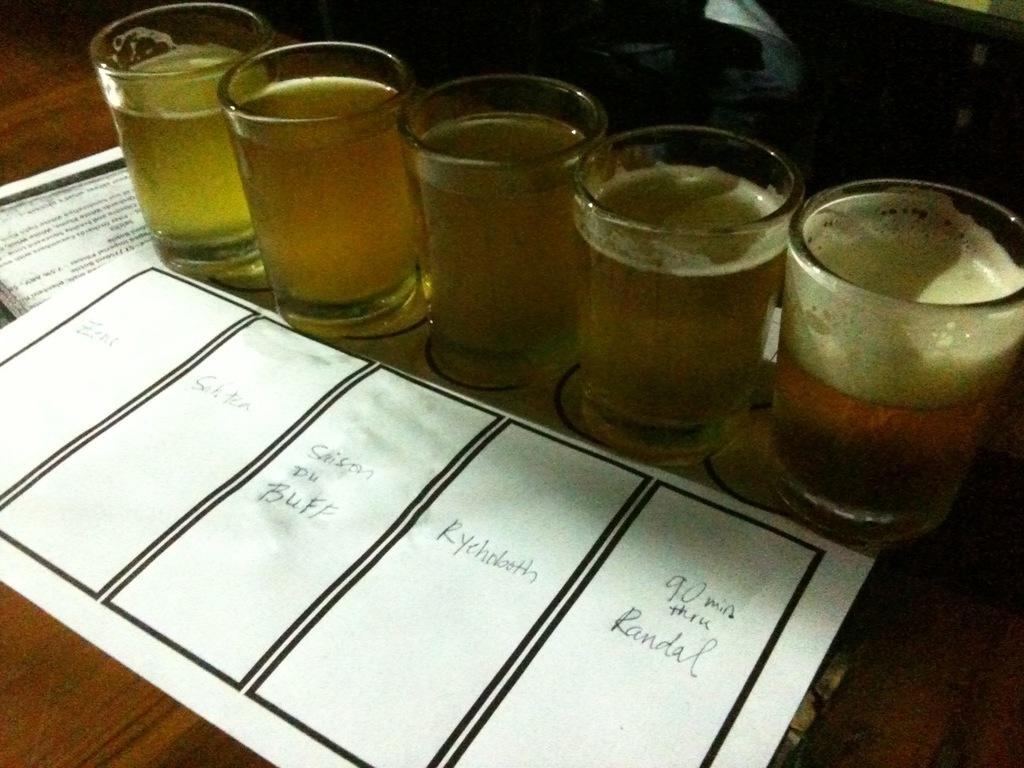What is contained in the glasses that are visible in the image? There are glasses with liquid in the image. What is the glasses placed on? The glasses are placed on paper. What type of surface is the paper resting on? The paper is on a wooden surface. Can you describe the objects visible at the top of the image? Unfortunately, the provided facts do not mention any objects visible at the top of the image. What type of cake is being served on the horse in the image? There is no cake or horse present in the image. 